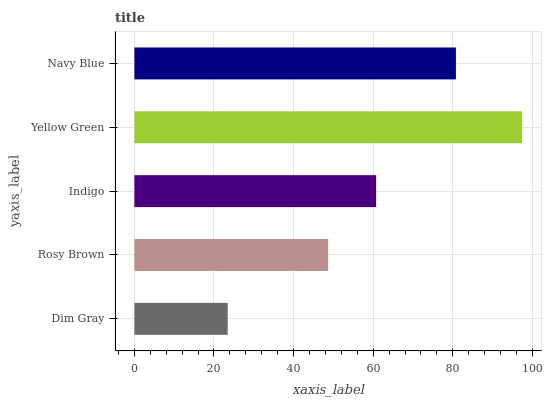Is Dim Gray the minimum?
Answer yes or no. Yes. Is Yellow Green the maximum?
Answer yes or no. Yes. Is Rosy Brown the minimum?
Answer yes or no. No. Is Rosy Brown the maximum?
Answer yes or no. No. Is Rosy Brown greater than Dim Gray?
Answer yes or no. Yes. Is Dim Gray less than Rosy Brown?
Answer yes or no. Yes. Is Dim Gray greater than Rosy Brown?
Answer yes or no. No. Is Rosy Brown less than Dim Gray?
Answer yes or no. No. Is Indigo the high median?
Answer yes or no. Yes. Is Indigo the low median?
Answer yes or no. Yes. Is Yellow Green the high median?
Answer yes or no. No. Is Dim Gray the low median?
Answer yes or no. No. 